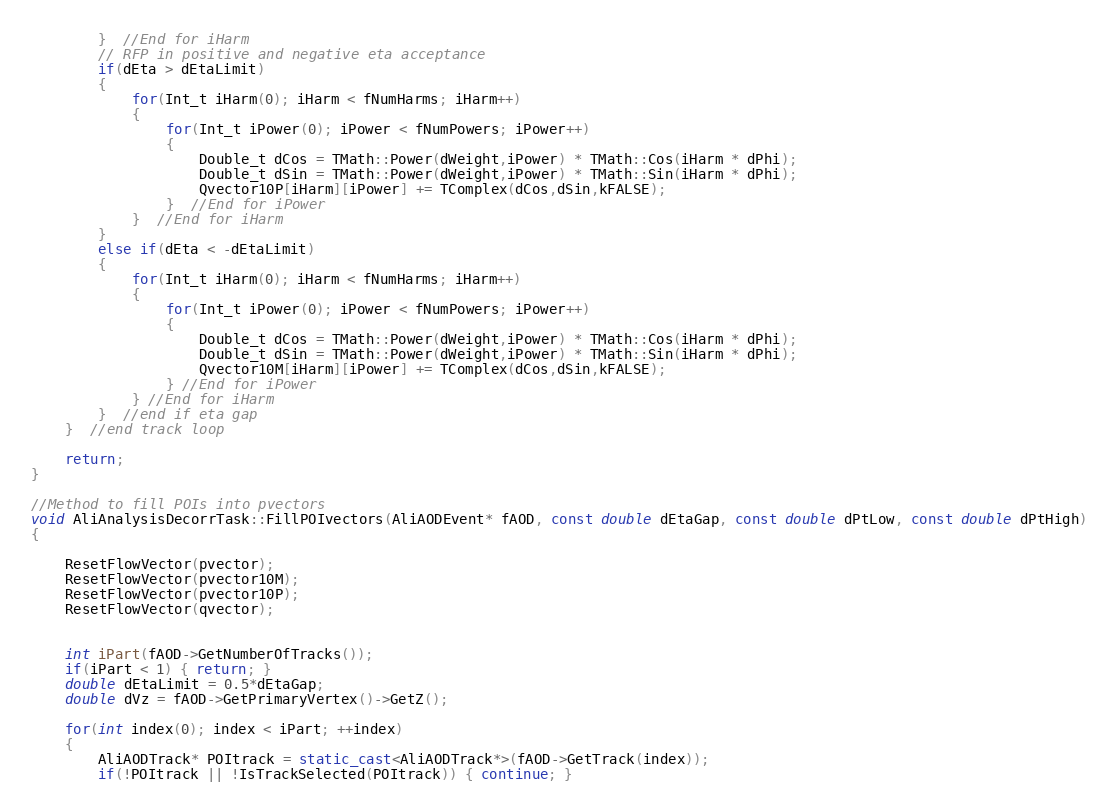Convert code to text. <code><loc_0><loc_0><loc_500><loc_500><_C++_>        }  //End for iHarm
        // RFP in positive and negative eta acceptance
        if(dEta > dEtaLimit)
        {
            for(Int_t iHarm(0); iHarm < fNumHarms; iHarm++)
            {
                for(Int_t iPower(0); iPower < fNumPowers; iPower++)
                {
                    Double_t dCos = TMath::Power(dWeight,iPower) * TMath::Cos(iHarm * dPhi);
                    Double_t dSin = TMath::Power(dWeight,iPower) * TMath::Sin(iHarm * dPhi);
                    Qvector10P[iHarm][iPower] += TComplex(dCos,dSin,kFALSE);
                }  //End for iPower
            }  //End for iHarm
        }
        else if(dEta < -dEtaLimit)
        {
            for(Int_t iHarm(0); iHarm < fNumHarms; iHarm++)
            {
                for(Int_t iPower(0); iPower < fNumPowers; iPower++)
                {
                    Double_t dCos = TMath::Power(dWeight,iPower) * TMath::Cos(iHarm * dPhi);
                    Double_t dSin = TMath::Power(dWeight,iPower) * TMath::Sin(iHarm * dPhi);
                    Qvector10M[iHarm][iPower] += TComplex(dCos,dSin,kFALSE);
                } //End for iPower
            } //End for iHarm
        }  //end if eta gap
    }  //end track loop

    return;
}

//Method to fill POIs into pvectors
void AliAnalysisDecorrTask::FillPOIvectors(AliAODEvent* fAOD, const double dEtaGap, const double dPtLow, const double dPtHigh)
{

    ResetFlowVector(pvector);
    ResetFlowVector(pvector10M);
    ResetFlowVector(pvector10P);
    ResetFlowVector(qvector);


    int iPart(fAOD->GetNumberOfTracks());
    if(iPart < 1) { return; }
    double dEtaLimit = 0.5*dEtaGap;
    double dVz = fAOD->GetPrimaryVertex()->GetZ();

    for(int index(0); index < iPart; ++index)
    {   
        AliAODTrack* POItrack = static_cast<AliAODTrack*>(fAOD->GetTrack(index));
        if(!POItrack || !IsTrackSelected(POItrack)) { continue; }
</code> 